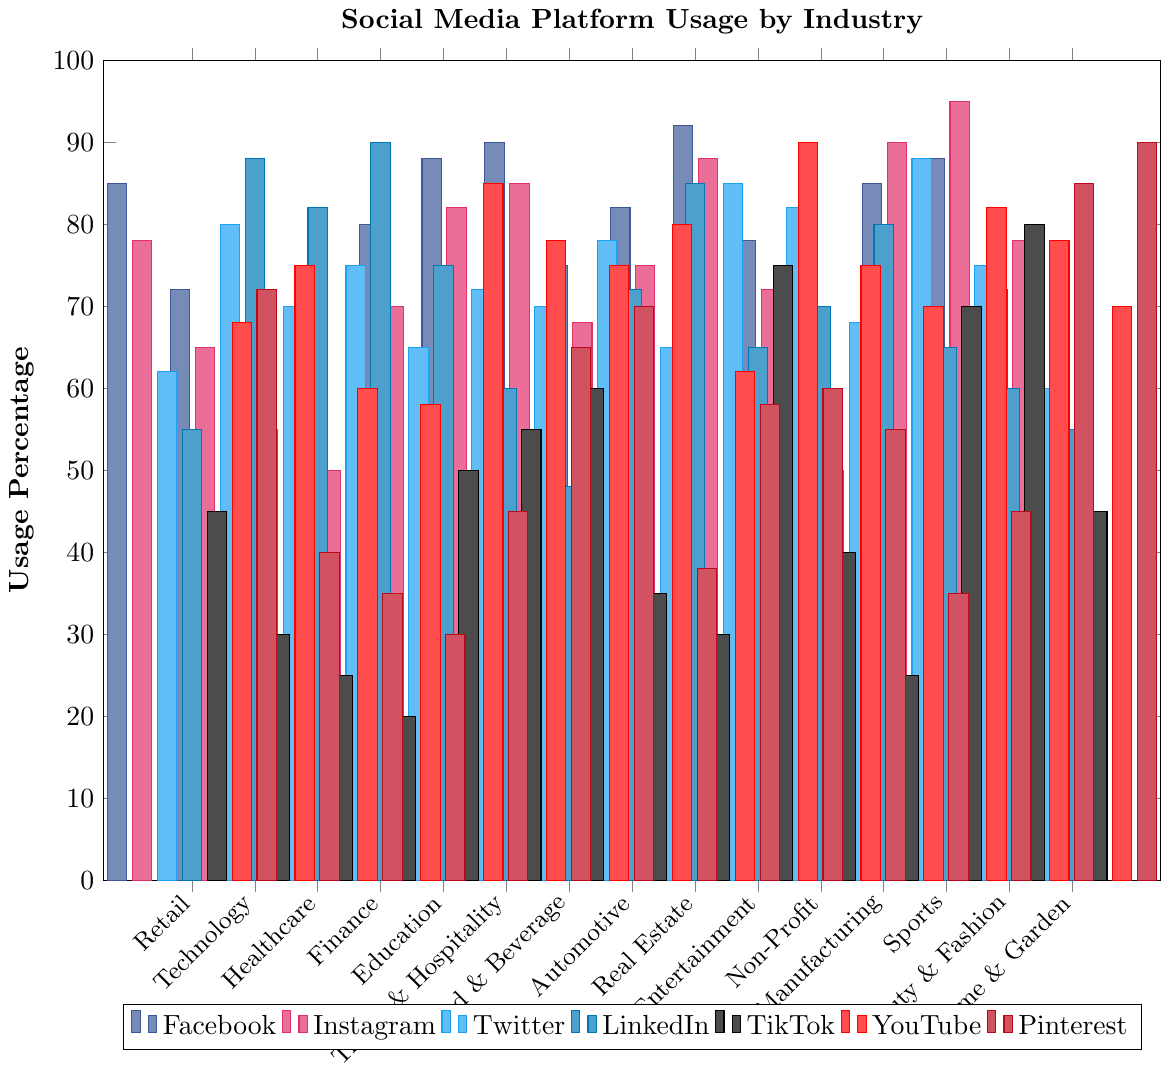What industry sector has the highest usage of Instagram? The bar representing Instagram usage is highest for the Beauty & Fashion industry.
Answer: Beauty & Fashion Which social media platform is least used in Healthcare? Compare the heights of all bars for Healthcare; the shortest bar represents TikTok.
Answer: TikTok What is the sum of YouTube usage percentages for Education and Entertainment? Add the YouTube usage percentages for both sectors: Education (85) + Entertainment (90).
Answer: 175 In the Finance sector, which platform has the smallest difference in usage percentage compared to Twitter? Calculate the absolute differences between Twitter (75) and other platforms: Facebook (5), Instagram (25), LinkedIn (15), TikTok (55), YouTube (17), Pinterest (45). The smallest difference is with Facebook.
Answer: Facebook What is the average usage percentage of Pinterest in all industry sectors? Sum the Pinterest usage percentages for all sectors and divide by the number of sectors: (72+40+35+30+45+65+70+38+58+60+55+35+45+85+90)/15. The sum is 823. The average is 823/15.
Answer: 54.87 Which social media platform is used more, Facebook in Technology or Instagram in Retail? Compare the heights of the bars for Facebook in Technology (72) and Instagram in Retail (78).
Answer: Instagram in Retail By how much does LinkedIn usage in Automotive differ from that in Real Estate? Subtract the LinkedIn usage of Real Estate (85) from that of Automotive (72).
Answer: 13 What is the difference in TikTok usage between Food & Beverage and Manufacturing? Subtract the TikTok usage in Manufacturing (25) from that in Food & Beverage (60).
Answer: 35 Which two industry sectors have the same YouTube usage, and what is that percentage? Look for identical heights of YouTube bars; Automotive and Food & Beverage both have a usage percentage of 75.
Answer: Automotive and Food & Beverage, 75 